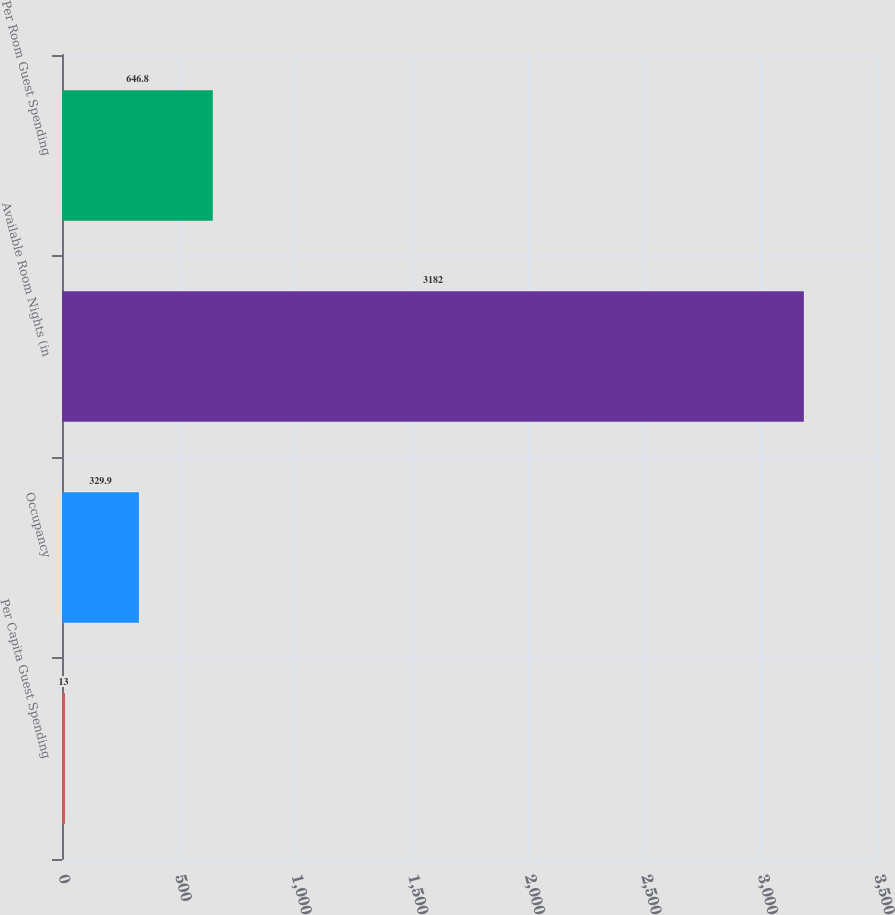Convert chart to OTSL. <chart><loc_0><loc_0><loc_500><loc_500><bar_chart><fcel>Per Capita Guest Spending<fcel>Occupancy<fcel>Available Room Nights (in<fcel>Per Room Guest Spending<nl><fcel>13<fcel>329.9<fcel>3182<fcel>646.8<nl></chart> 